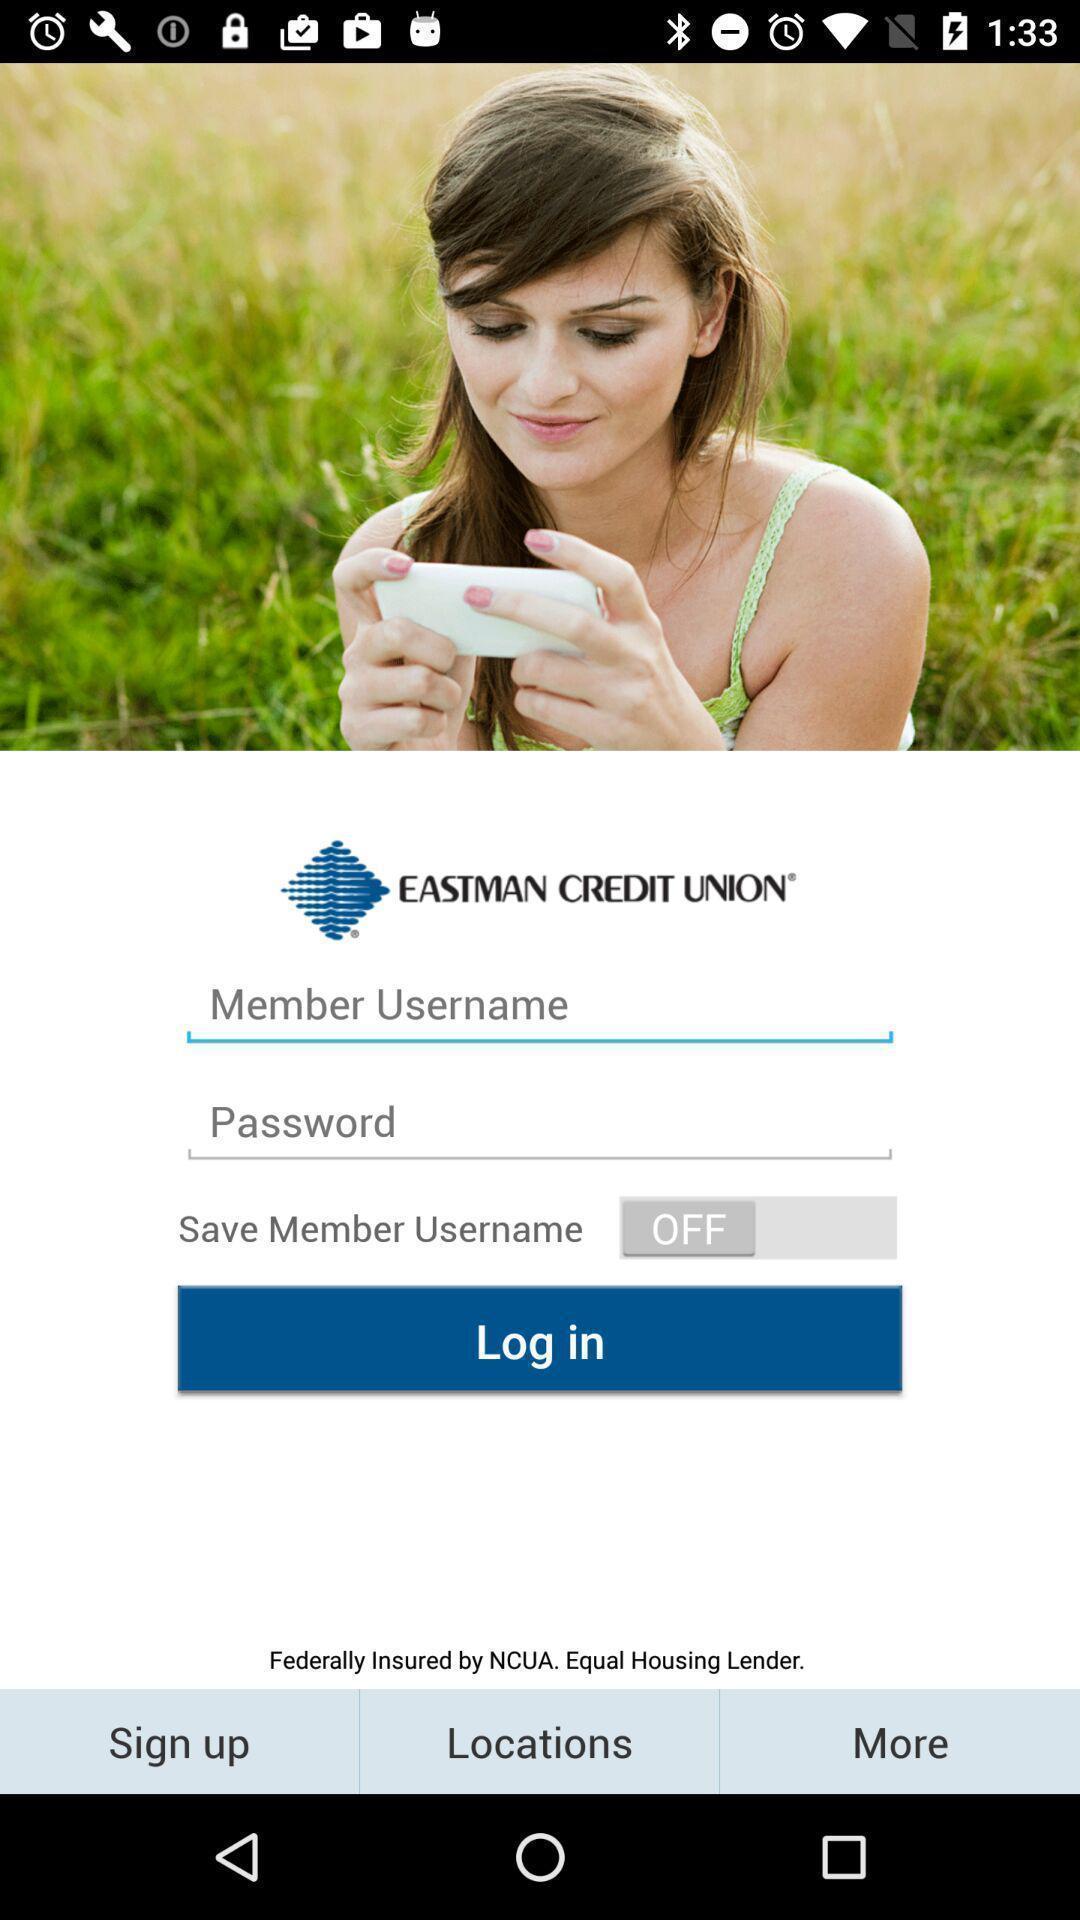Provide a description of this screenshot. Login page. 